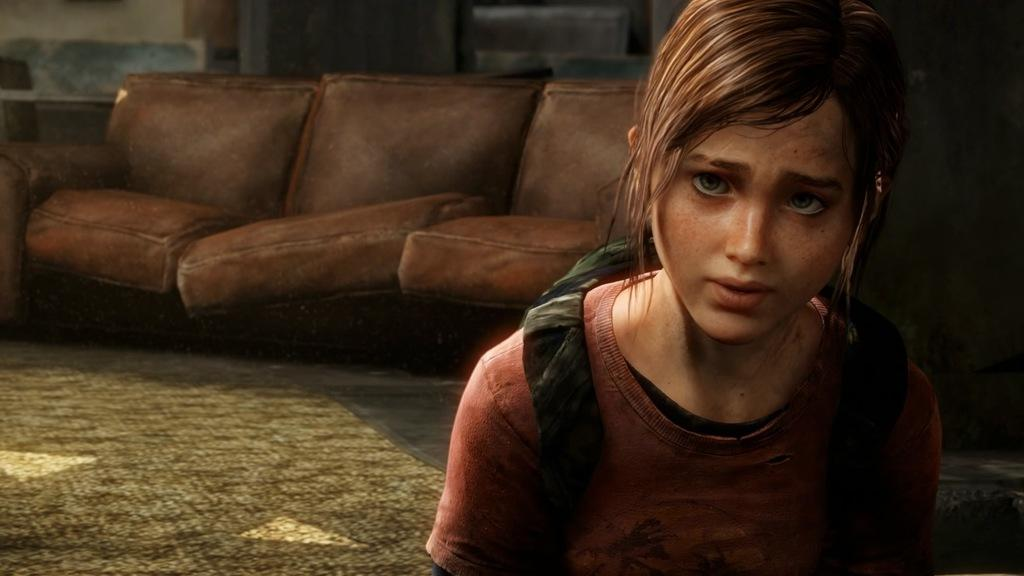What type of image is being described? The image appears to be an animation. Can you describe the main character in the image? There is a girl in the image. What is the girl wearing? The girl is wearing a backpack bag. What piece of furniture can be seen in the image? There is a couch in the image. What is the color of the couch? The couch has a brown color. What type of flooring is visible in the image? There is a carpet placed on the floor in the image. How many answers are visible on the floor in the image? There are no answers visible on the floor in the image. 